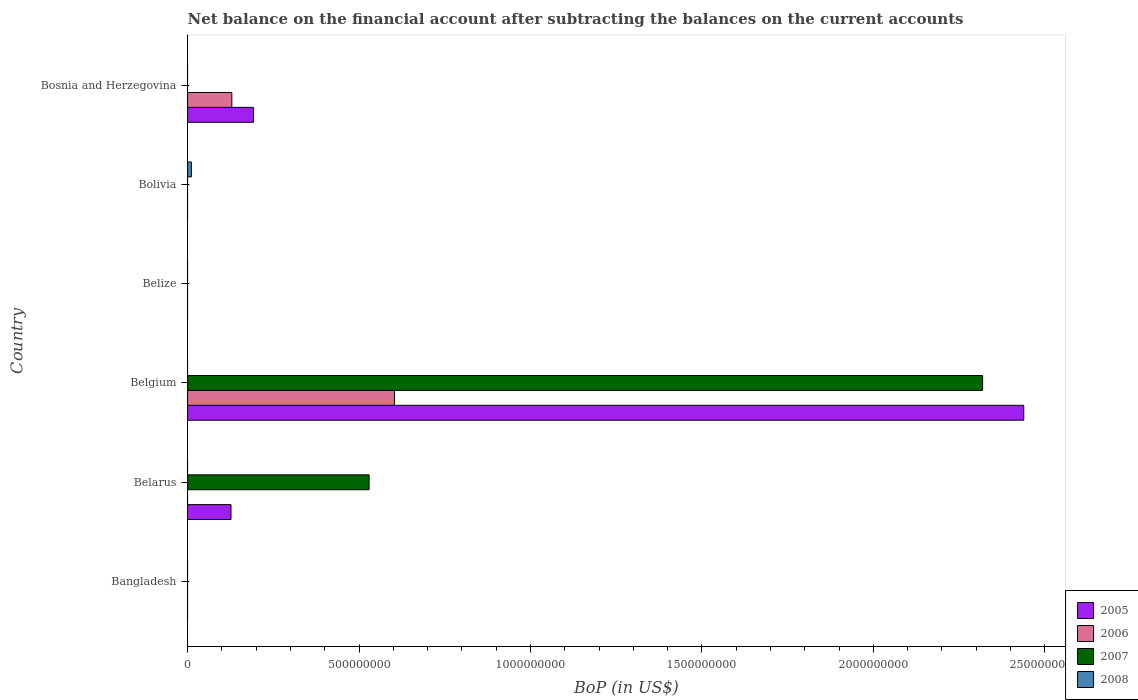How many different coloured bars are there?
Ensure brevity in your answer.  4. How many bars are there on the 1st tick from the top?
Your response must be concise. 2. Across all countries, what is the maximum Balance of Payments in 2007?
Ensure brevity in your answer.  2.32e+09. Across all countries, what is the minimum Balance of Payments in 2005?
Offer a very short reply. 0. In which country was the Balance of Payments in 2005 maximum?
Make the answer very short. Belgium. What is the total Balance of Payments in 2005 in the graph?
Your response must be concise. 2.76e+09. What is the difference between the Balance of Payments in 2005 in Belarus and that in Belgium?
Give a very brief answer. -2.31e+09. What is the difference between the Balance of Payments in 2005 in Belarus and the Balance of Payments in 2007 in Bangladesh?
Keep it short and to the point. 1.27e+08. What is the average Balance of Payments in 2005 per country?
Make the answer very short. 4.60e+08. In how many countries, is the Balance of Payments in 2007 greater than 1300000000 US$?
Keep it short and to the point. 1. Is the Balance of Payments in 2005 in Belgium less than that in Bosnia and Herzegovina?
Keep it short and to the point. No. What is the difference between the highest and the second highest Balance of Payments in 2005?
Your answer should be compact. 2.25e+09. What is the difference between the highest and the lowest Balance of Payments in 2007?
Your answer should be very brief. 2.32e+09. In how many countries, is the Balance of Payments in 2005 greater than the average Balance of Payments in 2005 taken over all countries?
Offer a terse response. 1. Is it the case that in every country, the sum of the Balance of Payments in 2008 and Balance of Payments in 2006 is greater than the sum of Balance of Payments in 2005 and Balance of Payments in 2007?
Your response must be concise. No. Is it the case that in every country, the sum of the Balance of Payments in 2006 and Balance of Payments in 2008 is greater than the Balance of Payments in 2005?
Keep it short and to the point. No. How many bars are there?
Make the answer very short. 8. Are the values on the major ticks of X-axis written in scientific E-notation?
Offer a terse response. No. How many legend labels are there?
Give a very brief answer. 4. What is the title of the graph?
Offer a very short reply. Net balance on the financial account after subtracting the balances on the current accounts. Does "1997" appear as one of the legend labels in the graph?
Provide a succinct answer. No. What is the label or title of the X-axis?
Give a very brief answer. BoP (in US$). What is the BoP (in US$) of 2006 in Bangladesh?
Keep it short and to the point. 0. What is the BoP (in US$) of 2007 in Bangladesh?
Provide a succinct answer. 0. What is the BoP (in US$) of 2005 in Belarus?
Offer a very short reply. 1.27e+08. What is the BoP (in US$) of 2007 in Belarus?
Your answer should be compact. 5.29e+08. What is the BoP (in US$) in 2008 in Belarus?
Offer a very short reply. 0. What is the BoP (in US$) of 2005 in Belgium?
Ensure brevity in your answer.  2.44e+09. What is the BoP (in US$) of 2006 in Belgium?
Ensure brevity in your answer.  6.03e+08. What is the BoP (in US$) of 2007 in Belgium?
Provide a short and direct response. 2.32e+09. What is the BoP (in US$) of 2005 in Belize?
Give a very brief answer. 0. What is the BoP (in US$) in 2007 in Belize?
Keep it short and to the point. 0. What is the BoP (in US$) in 2008 in Belize?
Make the answer very short. 0. What is the BoP (in US$) of 2005 in Bolivia?
Provide a short and direct response. 0. What is the BoP (in US$) of 2008 in Bolivia?
Ensure brevity in your answer.  1.10e+07. What is the BoP (in US$) of 2005 in Bosnia and Herzegovina?
Ensure brevity in your answer.  1.92e+08. What is the BoP (in US$) in 2006 in Bosnia and Herzegovina?
Offer a terse response. 1.29e+08. Across all countries, what is the maximum BoP (in US$) of 2005?
Ensure brevity in your answer.  2.44e+09. Across all countries, what is the maximum BoP (in US$) in 2006?
Make the answer very short. 6.03e+08. Across all countries, what is the maximum BoP (in US$) in 2007?
Provide a succinct answer. 2.32e+09. Across all countries, what is the maximum BoP (in US$) in 2008?
Your answer should be very brief. 1.10e+07. Across all countries, what is the minimum BoP (in US$) of 2005?
Offer a terse response. 0. Across all countries, what is the minimum BoP (in US$) of 2007?
Offer a terse response. 0. Across all countries, what is the minimum BoP (in US$) of 2008?
Your answer should be very brief. 0. What is the total BoP (in US$) of 2005 in the graph?
Ensure brevity in your answer.  2.76e+09. What is the total BoP (in US$) of 2006 in the graph?
Provide a short and direct response. 7.32e+08. What is the total BoP (in US$) of 2007 in the graph?
Your answer should be very brief. 2.85e+09. What is the total BoP (in US$) in 2008 in the graph?
Provide a short and direct response. 1.10e+07. What is the difference between the BoP (in US$) of 2005 in Belarus and that in Belgium?
Provide a short and direct response. -2.31e+09. What is the difference between the BoP (in US$) in 2007 in Belarus and that in Belgium?
Provide a short and direct response. -1.79e+09. What is the difference between the BoP (in US$) of 2005 in Belarus and that in Bosnia and Herzegovina?
Keep it short and to the point. -6.55e+07. What is the difference between the BoP (in US$) of 2005 in Belgium and that in Bosnia and Herzegovina?
Offer a terse response. 2.25e+09. What is the difference between the BoP (in US$) in 2006 in Belgium and that in Bosnia and Herzegovina?
Provide a succinct answer. 4.74e+08. What is the difference between the BoP (in US$) of 2005 in Belarus and the BoP (in US$) of 2006 in Belgium?
Ensure brevity in your answer.  -4.77e+08. What is the difference between the BoP (in US$) in 2005 in Belarus and the BoP (in US$) in 2007 in Belgium?
Provide a short and direct response. -2.19e+09. What is the difference between the BoP (in US$) in 2005 in Belarus and the BoP (in US$) in 2008 in Bolivia?
Keep it short and to the point. 1.16e+08. What is the difference between the BoP (in US$) of 2007 in Belarus and the BoP (in US$) of 2008 in Bolivia?
Offer a very short reply. 5.18e+08. What is the difference between the BoP (in US$) of 2005 in Belarus and the BoP (in US$) of 2006 in Bosnia and Herzegovina?
Your answer should be very brief. -2.43e+06. What is the difference between the BoP (in US$) of 2005 in Belgium and the BoP (in US$) of 2008 in Bolivia?
Your answer should be very brief. 2.43e+09. What is the difference between the BoP (in US$) of 2006 in Belgium and the BoP (in US$) of 2008 in Bolivia?
Give a very brief answer. 5.92e+08. What is the difference between the BoP (in US$) of 2007 in Belgium and the BoP (in US$) of 2008 in Bolivia?
Offer a terse response. 2.31e+09. What is the difference between the BoP (in US$) of 2005 in Belgium and the BoP (in US$) of 2006 in Bosnia and Herzegovina?
Ensure brevity in your answer.  2.31e+09. What is the average BoP (in US$) in 2005 per country?
Offer a terse response. 4.60e+08. What is the average BoP (in US$) in 2006 per country?
Provide a succinct answer. 1.22e+08. What is the average BoP (in US$) in 2007 per country?
Ensure brevity in your answer.  4.75e+08. What is the average BoP (in US$) in 2008 per country?
Give a very brief answer. 1.84e+06. What is the difference between the BoP (in US$) of 2005 and BoP (in US$) of 2007 in Belarus?
Offer a very short reply. -4.03e+08. What is the difference between the BoP (in US$) of 2005 and BoP (in US$) of 2006 in Belgium?
Your response must be concise. 1.84e+09. What is the difference between the BoP (in US$) in 2005 and BoP (in US$) in 2007 in Belgium?
Your response must be concise. 1.20e+08. What is the difference between the BoP (in US$) of 2006 and BoP (in US$) of 2007 in Belgium?
Offer a terse response. -1.72e+09. What is the difference between the BoP (in US$) in 2005 and BoP (in US$) in 2006 in Bosnia and Herzegovina?
Provide a succinct answer. 6.31e+07. What is the ratio of the BoP (in US$) in 2005 in Belarus to that in Belgium?
Provide a short and direct response. 0.05. What is the ratio of the BoP (in US$) of 2007 in Belarus to that in Belgium?
Provide a succinct answer. 0.23. What is the ratio of the BoP (in US$) in 2005 in Belarus to that in Bosnia and Herzegovina?
Provide a succinct answer. 0.66. What is the ratio of the BoP (in US$) in 2005 in Belgium to that in Bosnia and Herzegovina?
Offer a very short reply. 12.69. What is the ratio of the BoP (in US$) of 2006 in Belgium to that in Bosnia and Herzegovina?
Your answer should be very brief. 4.67. What is the difference between the highest and the second highest BoP (in US$) of 2005?
Provide a succinct answer. 2.25e+09. What is the difference between the highest and the lowest BoP (in US$) in 2005?
Your answer should be very brief. 2.44e+09. What is the difference between the highest and the lowest BoP (in US$) of 2006?
Offer a terse response. 6.03e+08. What is the difference between the highest and the lowest BoP (in US$) in 2007?
Offer a terse response. 2.32e+09. What is the difference between the highest and the lowest BoP (in US$) in 2008?
Your answer should be compact. 1.10e+07. 